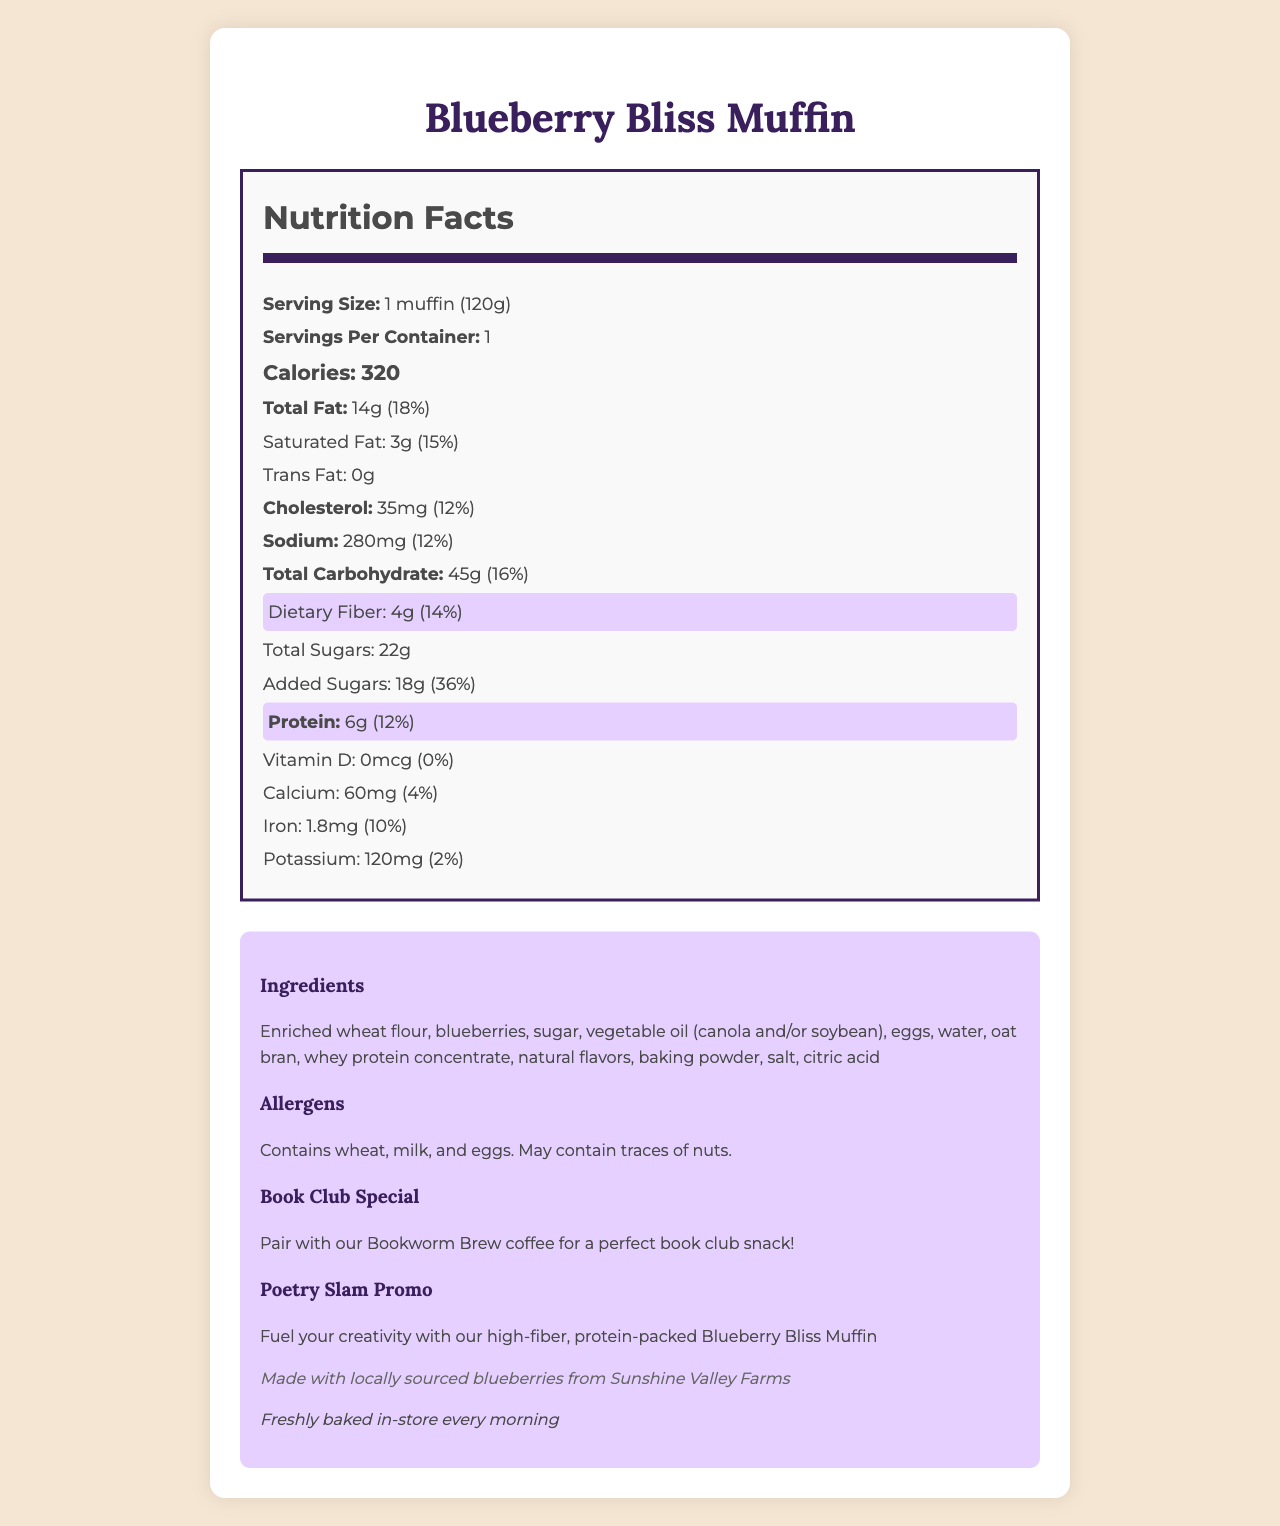what is the serving size of the Blueberry Bliss Muffin? The serving size is listed at the top of the Nutrition Facts label and is indicated as "1 muffin (120g)".
Answer: 1 muffin (120g) how many grams of dietary fiber does one muffin contain? The Nutrition Facts label highlights dietary fiber content, showing it contains 4g of fiber.
Answer: 4g what is the total calorie count for one muffin? The total calorie content is prominently displayed as "Calories: 320" in the Nutrition Facts section.
Answer: 320 calories what percentage of the daily value for protein does one muffin provide? The protein content and daily value percentage are given as "Protein: 6g (12%)" in the Nutrition Facts label.
Answer: 12% how much potassium is in a single muffin? The potassium content is listed under the Nutrition Facts label and shows "Potassium: 120mg (2%)".
Answer: 120mg what allergens are present in the muffin? The allergens section clearly states "Contains wheat, milk, and eggs. May contain traces of nuts."
Answer: Wheat, milk, and eggs how much total fat is in a single muffin? The total fat content is shown as "Total Fat: 14g (18%)" on the Nutrition Facts label.
Answer: 14g By pairing the muffin with our Bookworm Brew coffee, what special occasion is this promoting? The additional information section mentions "Pair with our Bookworm Brew coffee for a perfect book club snack!"
Answer: Book club meetings what is the main selling point of the Blueberry Bliss Muffin for poetry slams? The Poetry Slam Promo highlights "Fuel your creativity with our high-fiber, protein-packed Blueberry Bliss Muffin."
Answer: High-fiber, protein-packed which of the following nutrients does the Blueberry Bliss Muffin contain the least of? 1. Protein 2. Dietary Fiber 3. Vitamin D 4. Calcium The Nutrition Facts label indicates that Vitamin D has 0mcg, which is 0% of the daily value, the lowest among the listed nutrients.
Answer: 3. Vitamin D which ingredients are listed as the main ingredients in the Blueberry Bliss Muffin? A. Enriched wheat flour, blueberries, sugar B. Water, oat bran, whey protein concentrate C. Vegetable oil, eggs, baking powder D. Potato starch, rice flour, almond flour The ingredients section lists "Enriched wheat flour, blueberries, sugar" as the first three ingredients, making them the main ingredients.
Answer: A does the muffin contain any trans fat? The Nutrition Facts label states "Trans Fat: 0g".
Answer: No what is described about the sourcing of the blueberries in the muffin? The additional information mentions that the muffin is made with "locally sourced blueberries from Sunshine Valley Farms".
Answer: Made with locally sourced blueberries from Sunshine Valley Farms summarize the entire document. The document is a comprehensive presentation of the Blueberry Bliss Muffin, including its nutrition content, ingredient list, allergens, and promotional details for specific events.
Answer: The document presents the Nutrition Facts label for the Blueberry Bliss Muffin, detailing its serving size, calorie content, various nutrients including fiber and protein, and ingredients. It mentions allergens, special pairings for book club meetings, promotions for poetry slams, local sourcing of ingredients, and highlights its freshly baked preparation. how many vitamins and minerals are detailed in the nutritional information? The Nutrition Facts label details Vitamin D, Calcium, Iron, and Potassium, making a total of four vitamins and minerals.
Answer: 4 is there more added sugar or total sugars in the muffin? The label shows "Total Sugars: 22g" and "Added Sugars: 18g". While 18g of the sugars are added, the total sugars include these plus naturally occurring sugars in the ingredients.
Answer: Total sugars what is the specific reason that boundaries or borders (e.g., "borders Laboratory" feature in the nutritional document) exist? The document does not provide details on why specific formatting choices, such as borders, are used.
Answer: Not enough information 